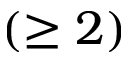<formula> <loc_0><loc_0><loc_500><loc_500>( \geq 2 )</formula> 